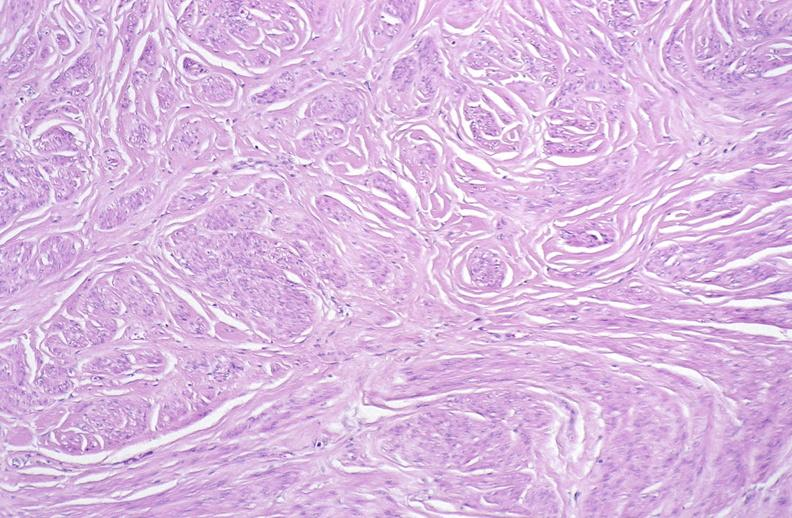does left ventricle hypertrophy show leiomyoma, uterus?
Answer the question using a single word or phrase. No 